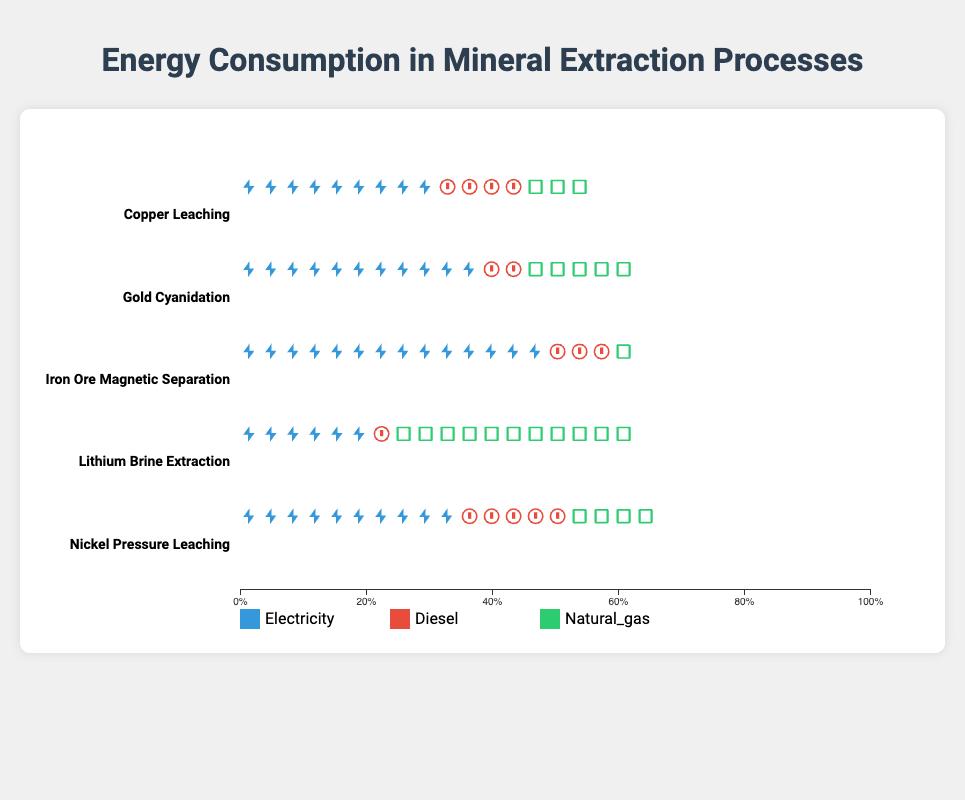What is the process with the highest electricity consumption? By checking each process's electricity consumption represented by blue icons, we see that Iron Ore Magnetic Separation has the highest count of blue icons.
Answer: Iron Ore Magnetic Separation Which energy source is used the most in Lithium Brine Extraction? By comparing the count of different colored icons (blue for electricity, red for diesel, and green for natural gas), the green icons representing natural gas are the most numerous for Lithium Brine Extraction.
Answer: Natural Gas How does the diesel consumption of Gold Cyanidation compare to that of Nickel Pressure Leaching? Gold Cyanidation has fewer red icons (representing diesel) than Nickel Pressure Leaching when visually comparing the number of red icons.
Answer: Less What's the total percentage of energy consumption from electricity for Copper Leaching? Summing the number of icons for electricity, diesel, and natural gas in Copper Leaching and calculating the percentage of blue icons among them, the calculation is roughly 45%.
Answer: 45% Which mineral extraction process has the least natural gas consumption? By counting the green icons (natural gas) across all processes, Iron Ore Magnetic Separation has the fewest green icons.
Answer: Iron Ore Magnetic Separation Compare the total energy consumption of Diesel and Natural Gas for Lithium Brine Extraction. Which is higher? By counting and comparing the red and green icons in Lithium Brine Extraction, it is clear that the green icons (natural gas) outnumber the red icons (diesel).
Answer: Natural Gas What is the combined diesel percentage consumption across all processes? Summing the red icons (representing diesel) for each process, then calculating the percentage of this sum out of the total icons for all processes, yields the combined percentage.
Answer: 15% Identify the process with the most balanced energy consumption across all three sources. By examining the evenness in the counts of blue, red, and green icons across each process, Copper Leaching shows the most balanced distribution.
Answer: Copper Leaching Which two processes have the most similar electricity consumption? By visually comparing the counts of blue icons, Copper Leaching and Nickel Pressure Leaching have similar figures.
Answer: Copper Leaching and Nickel Pressure Leaching Determine the percentage difference in natural gas usage between Gold Cyanidation and Nickel Pressure Leaching. Counting the green icons (natural gas) for both Gold Cyanidation and Nickel Pressure Leaching and finding the difference between their proportions relative to total icons in each process shows there's a 5% difference.
Answer: 5% 